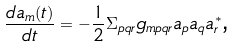<formula> <loc_0><loc_0><loc_500><loc_500>\frac { d a _ { m } ( t ) } { d t } = - \frac { 1 } { 2 } \Sigma _ { p q r } g _ { m p q r } a _ { p } a _ { q } a _ { r } ^ { * } \text {,}</formula> 